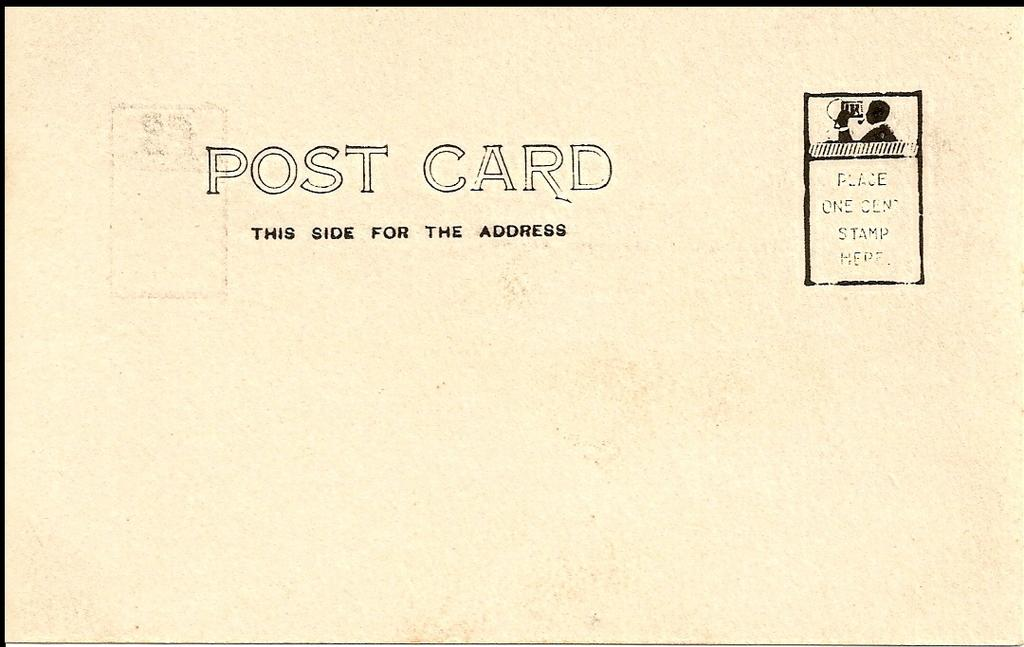Provide a one-sentence caption for the provided image. Post card with this side for the address on the front. 